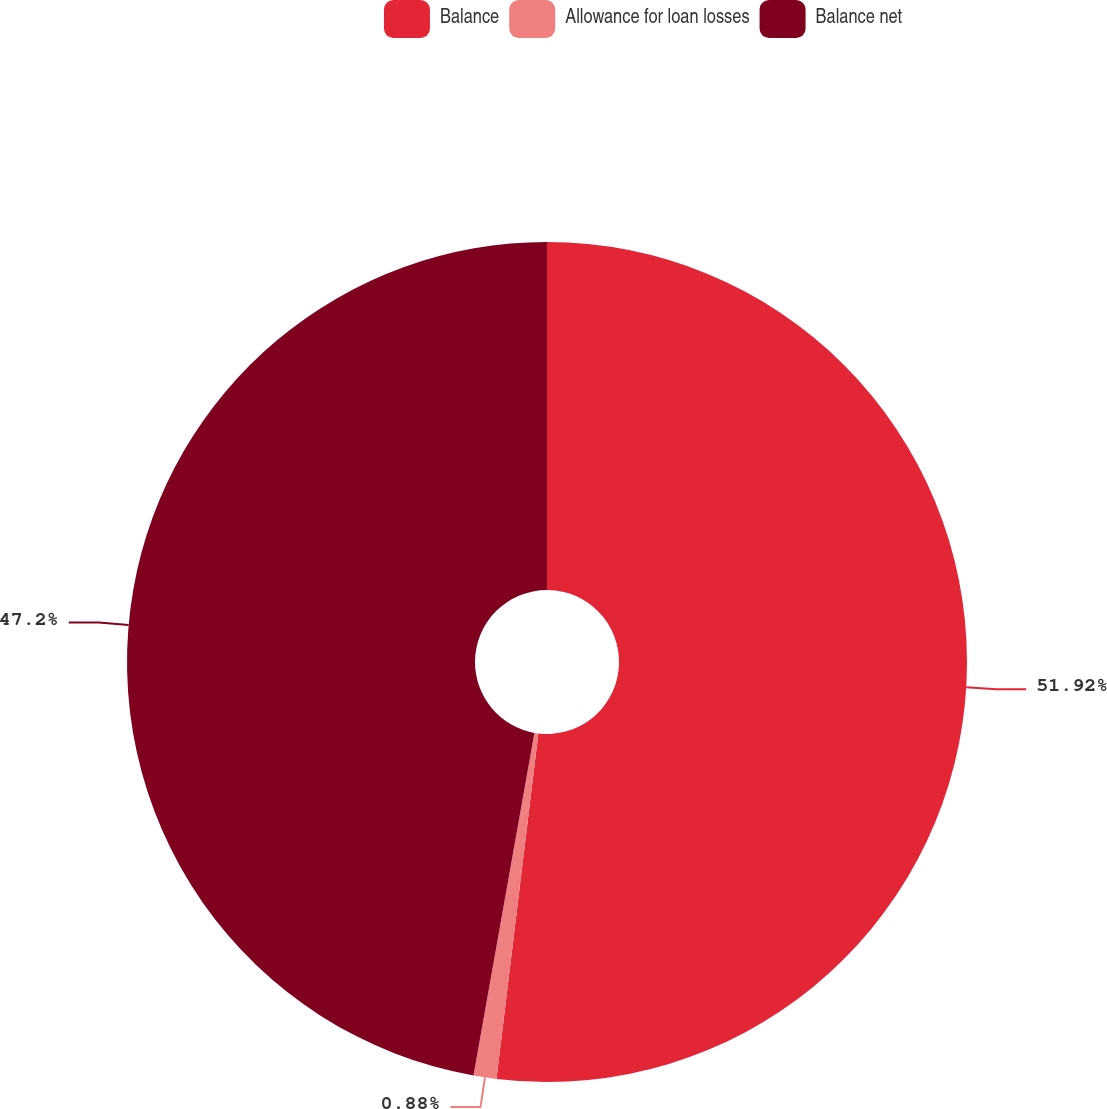Convert chart to OTSL. <chart><loc_0><loc_0><loc_500><loc_500><pie_chart><fcel>Balance<fcel>Allowance for loan losses<fcel>Balance net<nl><fcel>51.92%<fcel>0.88%<fcel>47.2%<nl></chart> 